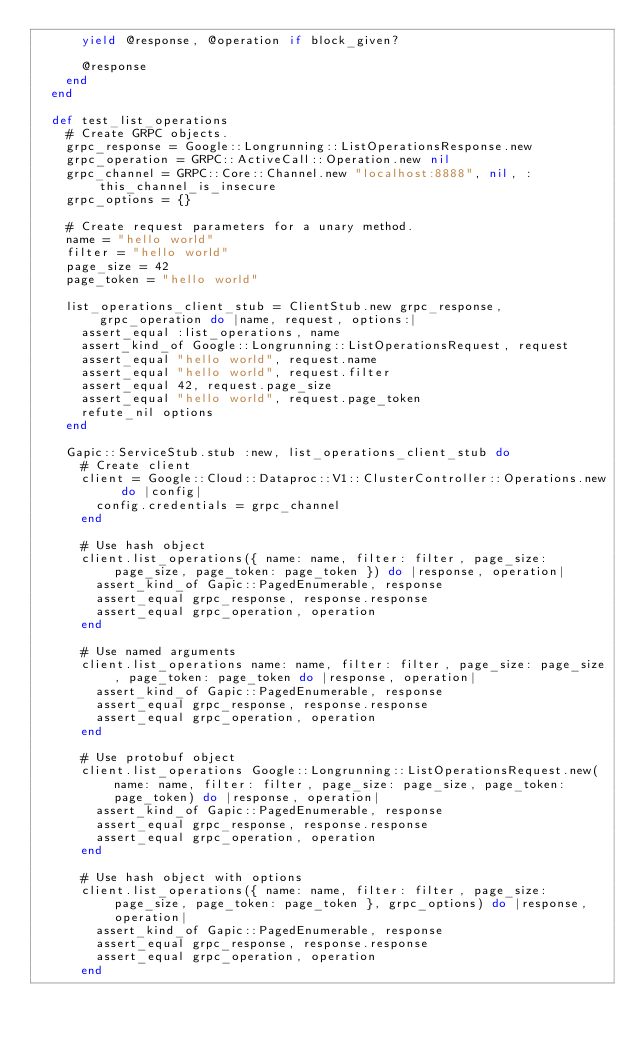Convert code to text. <code><loc_0><loc_0><loc_500><loc_500><_Ruby_>      yield @response, @operation if block_given?

      @response
    end
  end

  def test_list_operations
    # Create GRPC objects.
    grpc_response = Google::Longrunning::ListOperationsResponse.new
    grpc_operation = GRPC::ActiveCall::Operation.new nil
    grpc_channel = GRPC::Core::Channel.new "localhost:8888", nil, :this_channel_is_insecure
    grpc_options = {}

    # Create request parameters for a unary method.
    name = "hello world"
    filter = "hello world"
    page_size = 42
    page_token = "hello world"

    list_operations_client_stub = ClientStub.new grpc_response, grpc_operation do |name, request, options:|
      assert_equal :list_operations, name
      assert_kind_of Google::Longrunning::ListOperationsRequest, request
      assert_equal "hello world", request.name
      assert_equal "hello world", request.filter
      assert_equal 42, request.page_size
      assert_equal "hello world", request.page_token
      refute_nil options
    end

    Gapic::ServiceStub.stub :new, list_operations_client_stub do
      # Create client
      client = Google::Cloud::Dataproc::V1::ClusterController::Operations.new do |config|
        config.credentials = grpc_channel
      end

      # Use hash object
      client.list_operations({ name: name, filter: filter, page_size: page_size, page_token: page_token }) do |response, operation|
        assert_kind_of Gapic::PagedEnumerable, response
        assert_equal grpc_response, response.response
        assert_equal grpc_operation, operation
      end

      # Use named arguments
      client.list_operations name: name, filter: filter, page_size: page_size, page_token: page_token do |response, operation|
        assert_kind_of Gapic::PagedEnumerable, response
        assert_equal grpc_response, response.response
        assert_equal grpc_operation, operation
      end

      # Use protobuf object
      client.list_operations Google::Longrunning::ListOperationsRequest.new(name: name, filter: filter, page_size: page_size, page_token: page_token) do |response, operation|
        assert_kind_of Gapic::PagedEnumerable, response
        assert_equal grpc_response, response.response
        assert_equal grpc_operation, operation
      end

      # Use hash object with options
      client.list_operations({ name: name, filter: filter, page_size: page_size, page_token: page_token }, grpc_options) do |response, operation|
        assert_kind_of Gapic::PagedEnumerable, response
        assert_equal grpc_response, response.response
        assert_equal grpc_operation, operation
      end
</code> 